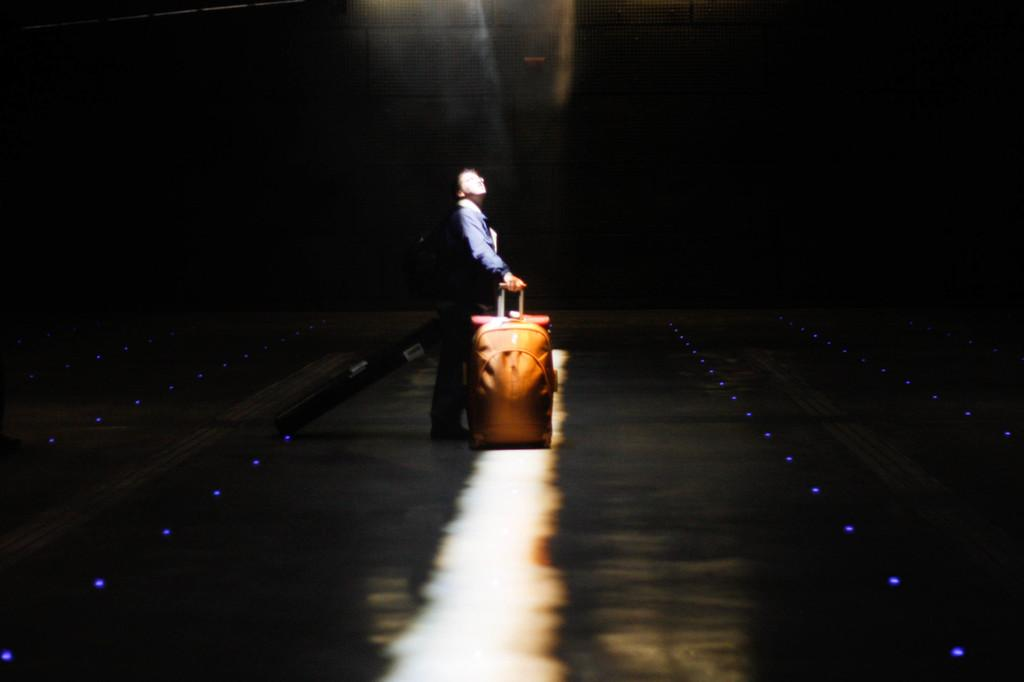Who is present in the image? There is a man in the image. What is the man doing in the image? The man is standing in the image. What is the man holding in the image? The man is holding a bag in the image. What color is the bag the man is holding? The bag is brown in color. Where is the man standing in the image? The man appears to be standing on a road in the image. What is the lighting condition in the image? The background of the image is dark. How many snakes can be seen slithering on the calendar in the image? There are no snakes or calendars present in the image. What is the man attempting to do in the image? The image does not provide information about any attempts or actions the man is trying to perform. 